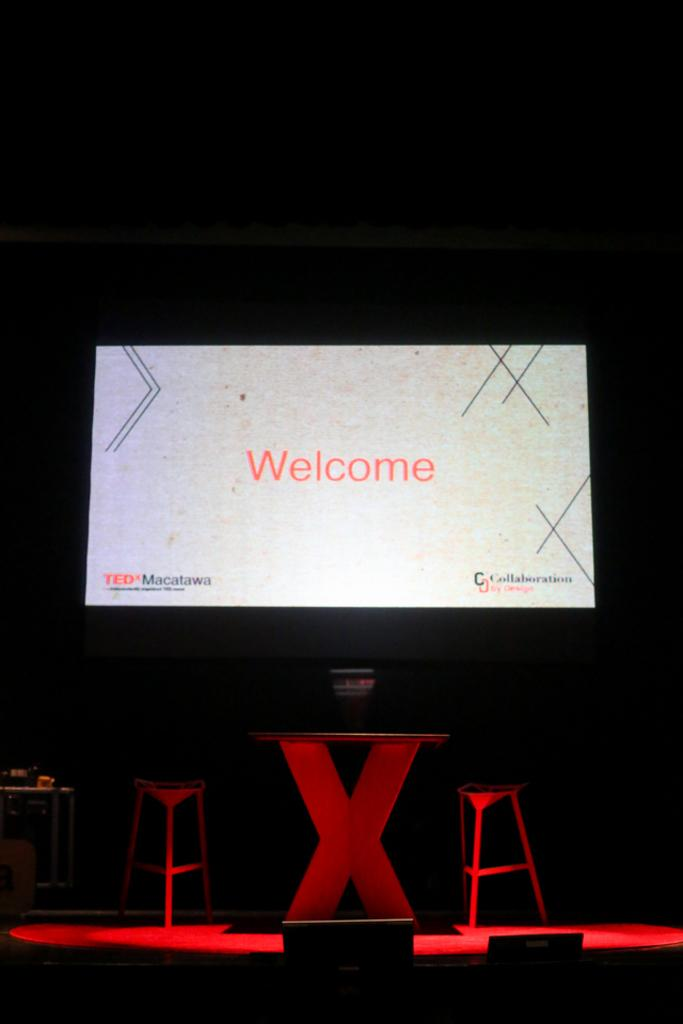<image>
Write a terse but informative summary of the picture. A large, flat screen monitor that says "Welcome" is located above a round table and two stools. 